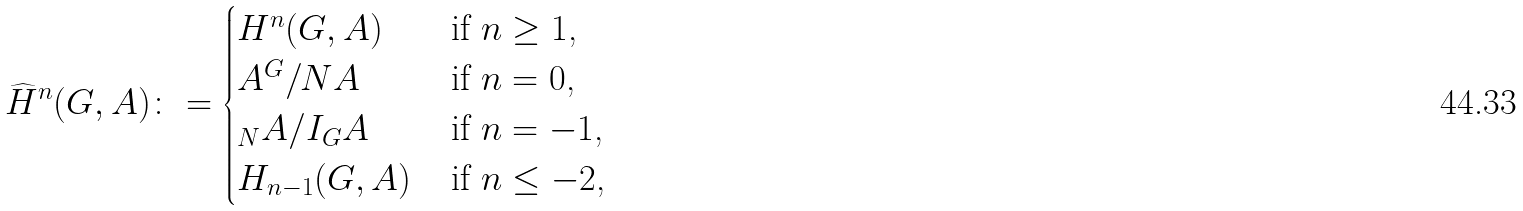<formula> <loc_0><loc_0><loc_500><loc_500>\widehat { H } ^ { n } ( G , A ) \colon = \begin{cases} H ^ { n } ( G , A ) \, & \text {if $n \geq 1$,} \\ A ^ { G } / N A \, & \text {if $n = 0$,} \\ _ { N } A / I _ { G } A \, & \text {if $n = -1$,} \\ H _ { n - 1 } ( G , A ) \, & \text {if $n \leq - 2$,} \end{cases}</formula> 